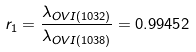Convert formula to latex. <formula><loc_0><loc_0><loc_500><loc_500>r _ { 1 } = \frac { \lambda _ { O V I ( 1 0 3 2 \AA ) } } { \lambda _ { O V I ( 1 0 3 8 \AA ) } } = 0 . 9 9 4 5 2</formula> 